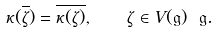Convert formula to latex. <formula><loc_0><loc_0><loc_500><loc_500>\kappa ( \overline { \zeta } ) = \overline { \kappa ( \zeta ) } , \quad \zeta \in V ( \mathfrak { g } ) \ \mathfrak { g } .</formula> 